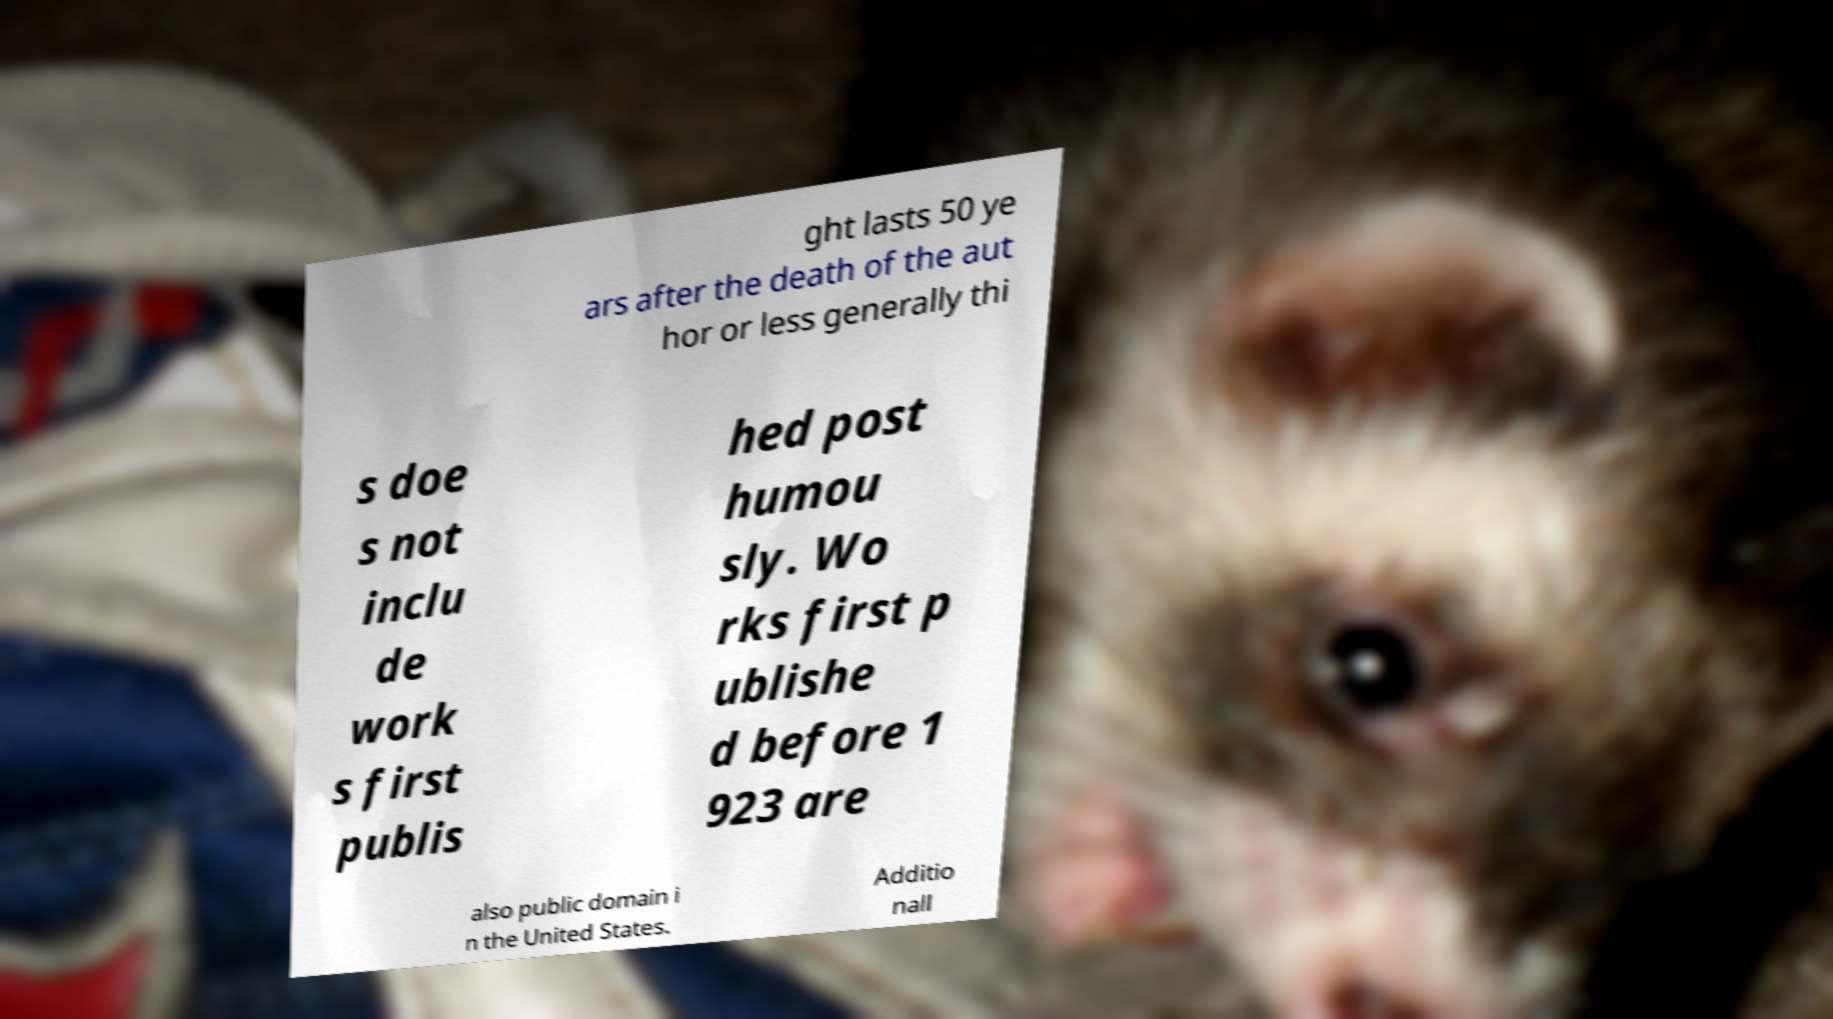Please identify and transcribe the text found in this image. ght lasts 50 ye ars after the death of the aut hor or less generally thi s doe s not inclu de work s first publis hed post humou sly. Wo rks first p ublishe d before 1 923 are also public domain i n the United States. Additio nall 